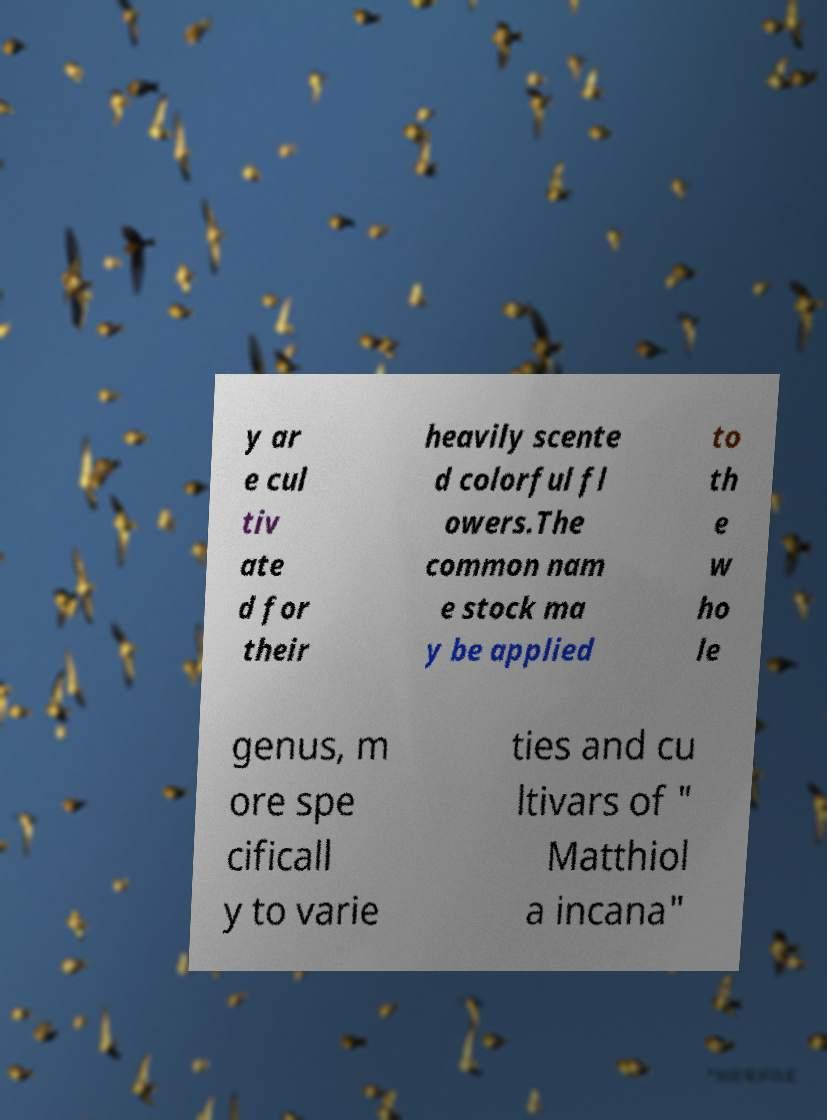What messages or text are displayed in this image? I need them in a readable, typed format. y ar e cul tiv ate d for their heavily scente d colorful fl owers.The common nam e stock ma y be applied to th e w ho le genus, m ore spe cificall y to varie ties and cu ltivars of " Matthiol a incana" 